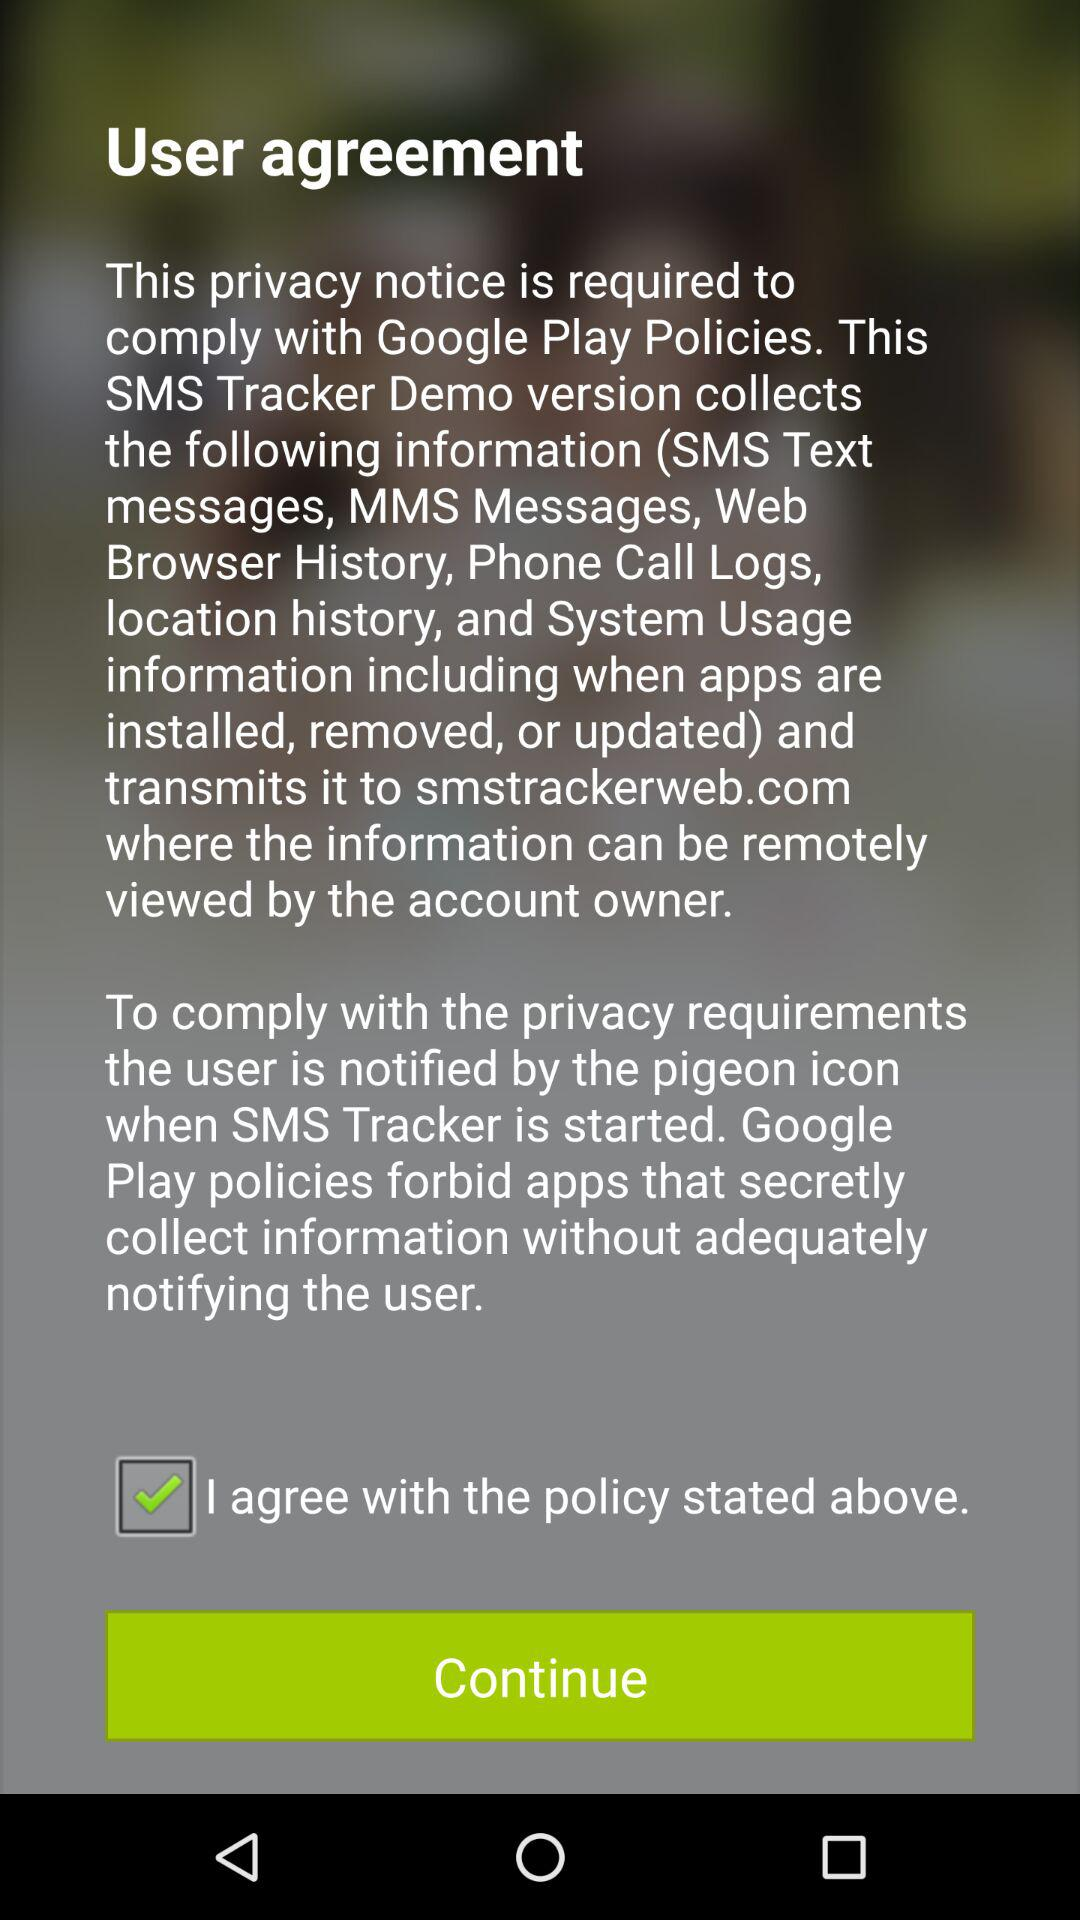What is the status of the option that includes agreement with the policy? The status of the option that includes agreement with the policy is "on". 